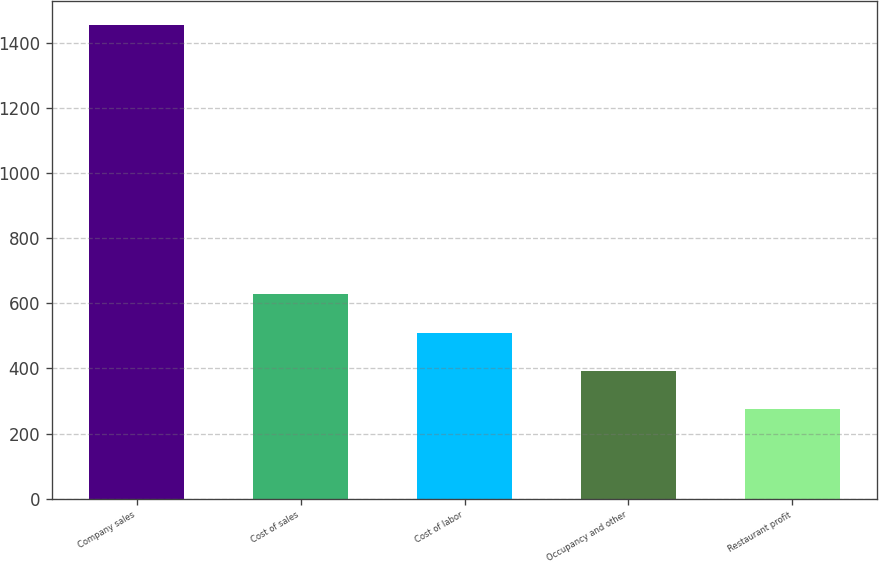Convert chart to OTSL. <chart><loc_0><loc_0><loc_500><loc_500><bar_chart><fcel>Company sales<fcel>Cost of sales<fcel>Cost of labor<fcel>Occupancy and other<fcel>Restaurant profit<nl><fcel>1454<fcel>628<fcel>510<fcel>392<fcel>274<nl></chart> 